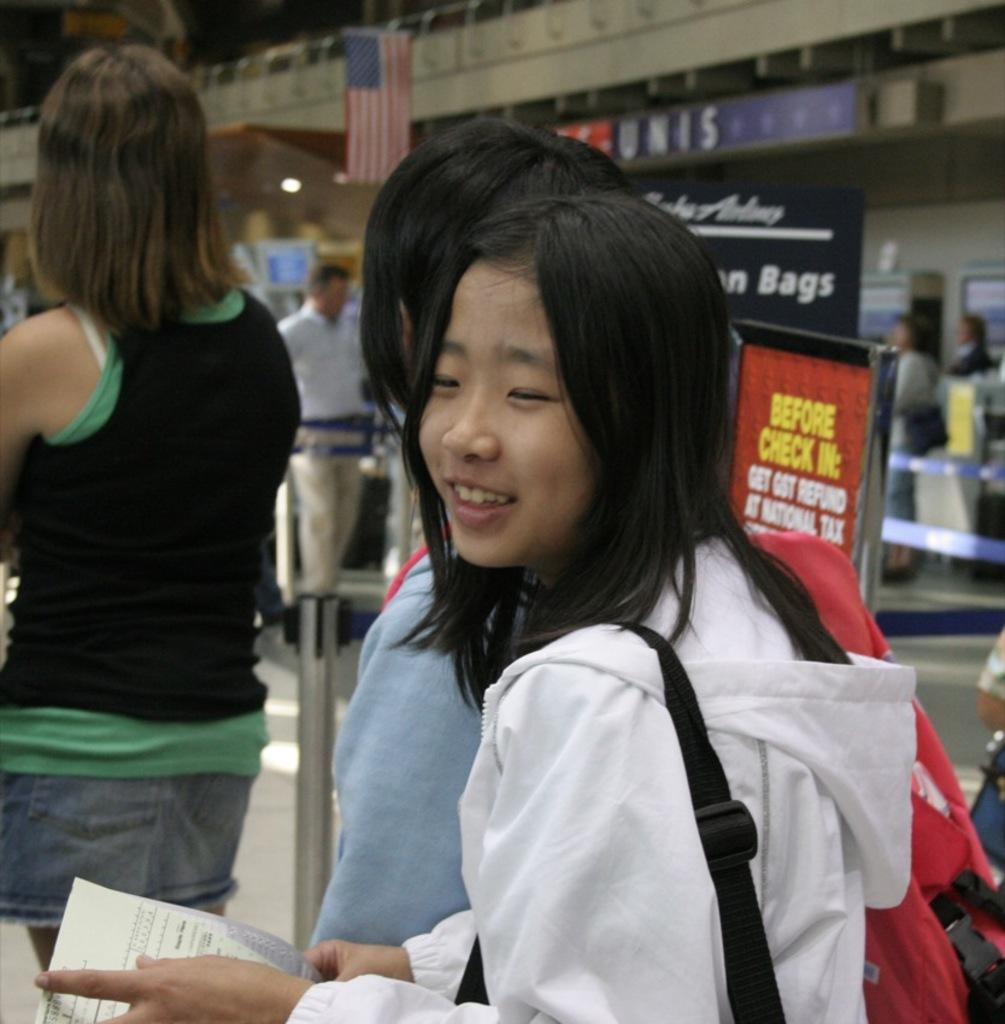How many people are present in the image? There are people in the image, but the exact number is not specified. What is one person holding in the image? One person is holding a paper. What is another person holding in the image? Another person is holding a wire bag. What can be seen in the background of the image? In the background of the image, there is a wall, a banner, a board, a flag, and people. What type of ear can be seen on the person holding the paper in the image? There is no mention of an ear or any body part in the image. The focus is on the people holding a paper and a wire bag, as well as the background elements. 